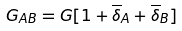<formula> <loc_0><loc_0><loc_500><loc_500>G _ { A B } = G [ 1 + \overline { \delta } _ { A } + \overline { \delta } _ { B } ]</formula> 